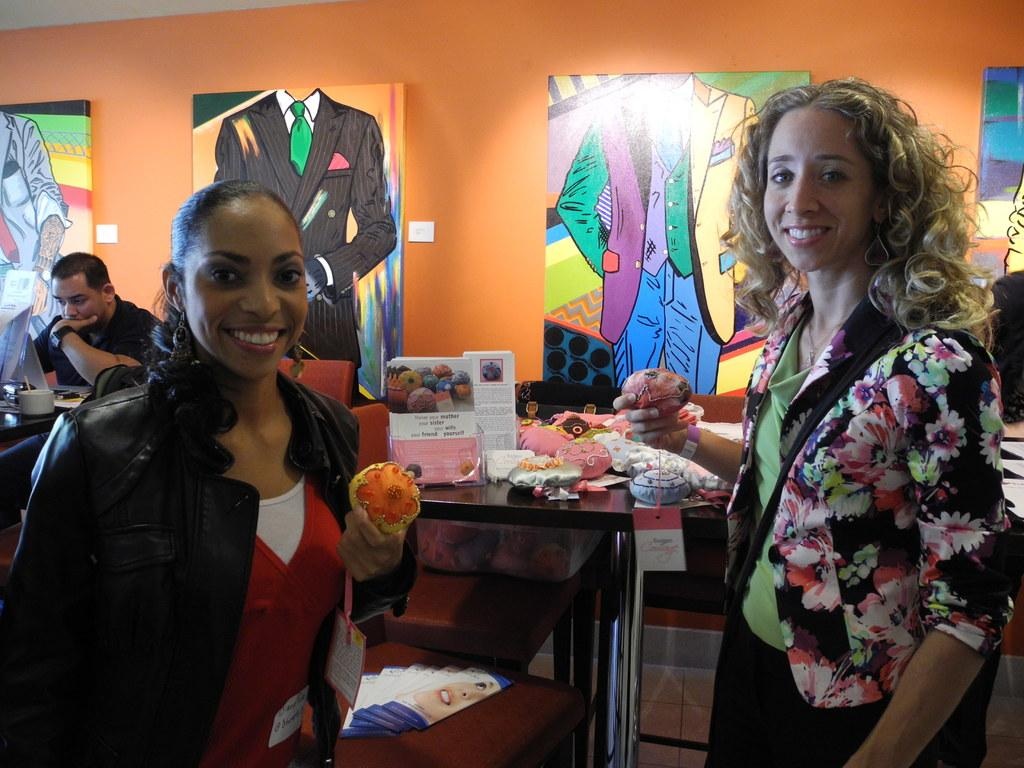How many people are in the image? There are two persons in the image. What are the persons wearing? The persons are wearing clothes. What are the persons holding in their hands? The persons are holding something with their hands. What is in the middle of the image? There is a table in the middle of the image. What can be seen on the wall in the image? There are boards on the wall. Can you tell me how many trucks are parked behind the persons in the image? There are no trucks visible in the image; it only shows two persons, a table, and boards on the wall. 